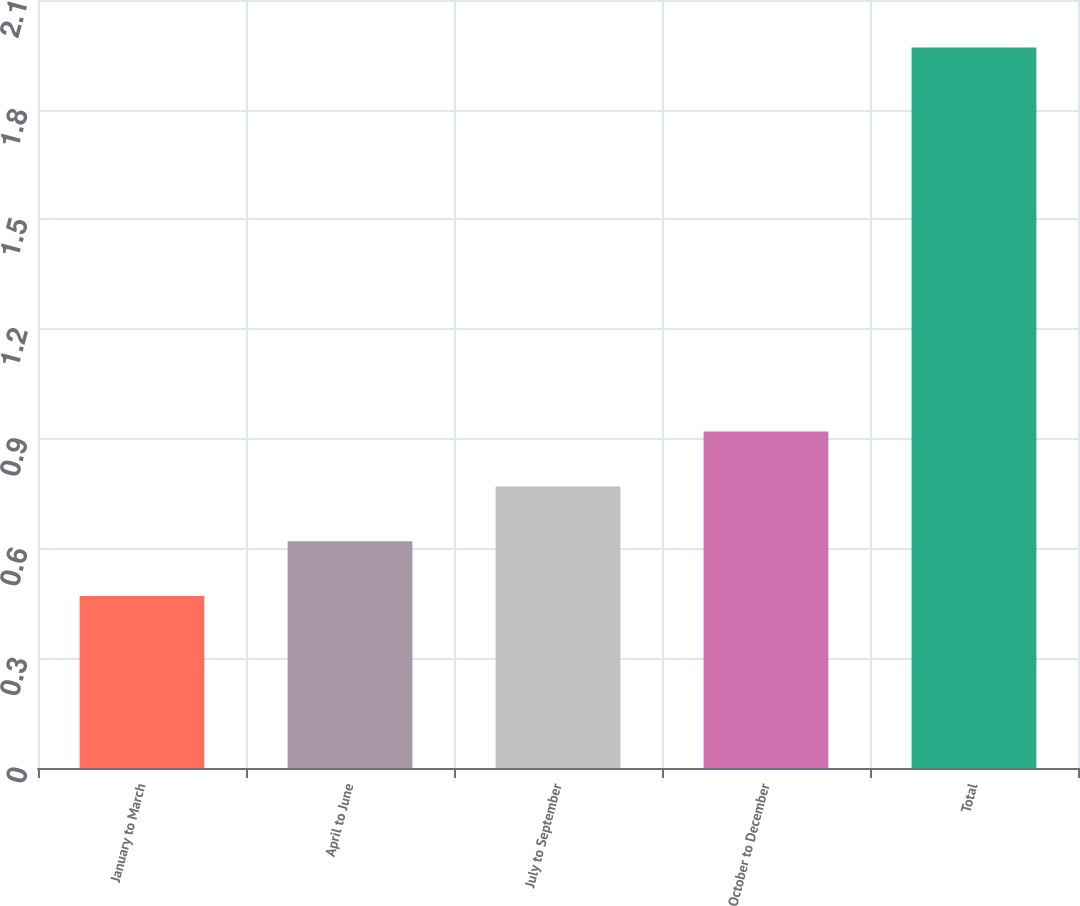Convert chart. <chart><loc_0><loc_0><loc_500><loc_500><bar_chart><fcel>January to March<fcel>April to June<fcel>July to September<fcel>October to December<fcel>Total<nl><fcel>0.47<fcel>0.62<fcel>0.77<fcel>0.92<fcel>1.97<nl></chart> 